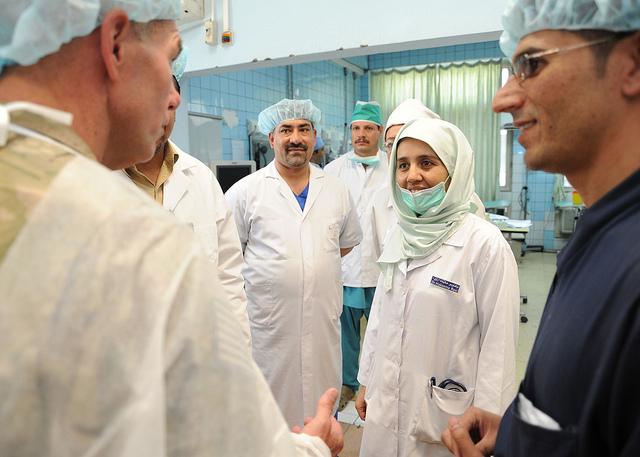Which man has wears glasses?
Write a very short answer. One in blue shirt. How many men are there?
Keep it brief. 5. Where are these people at?
Give a very brief answer. Hospital. 